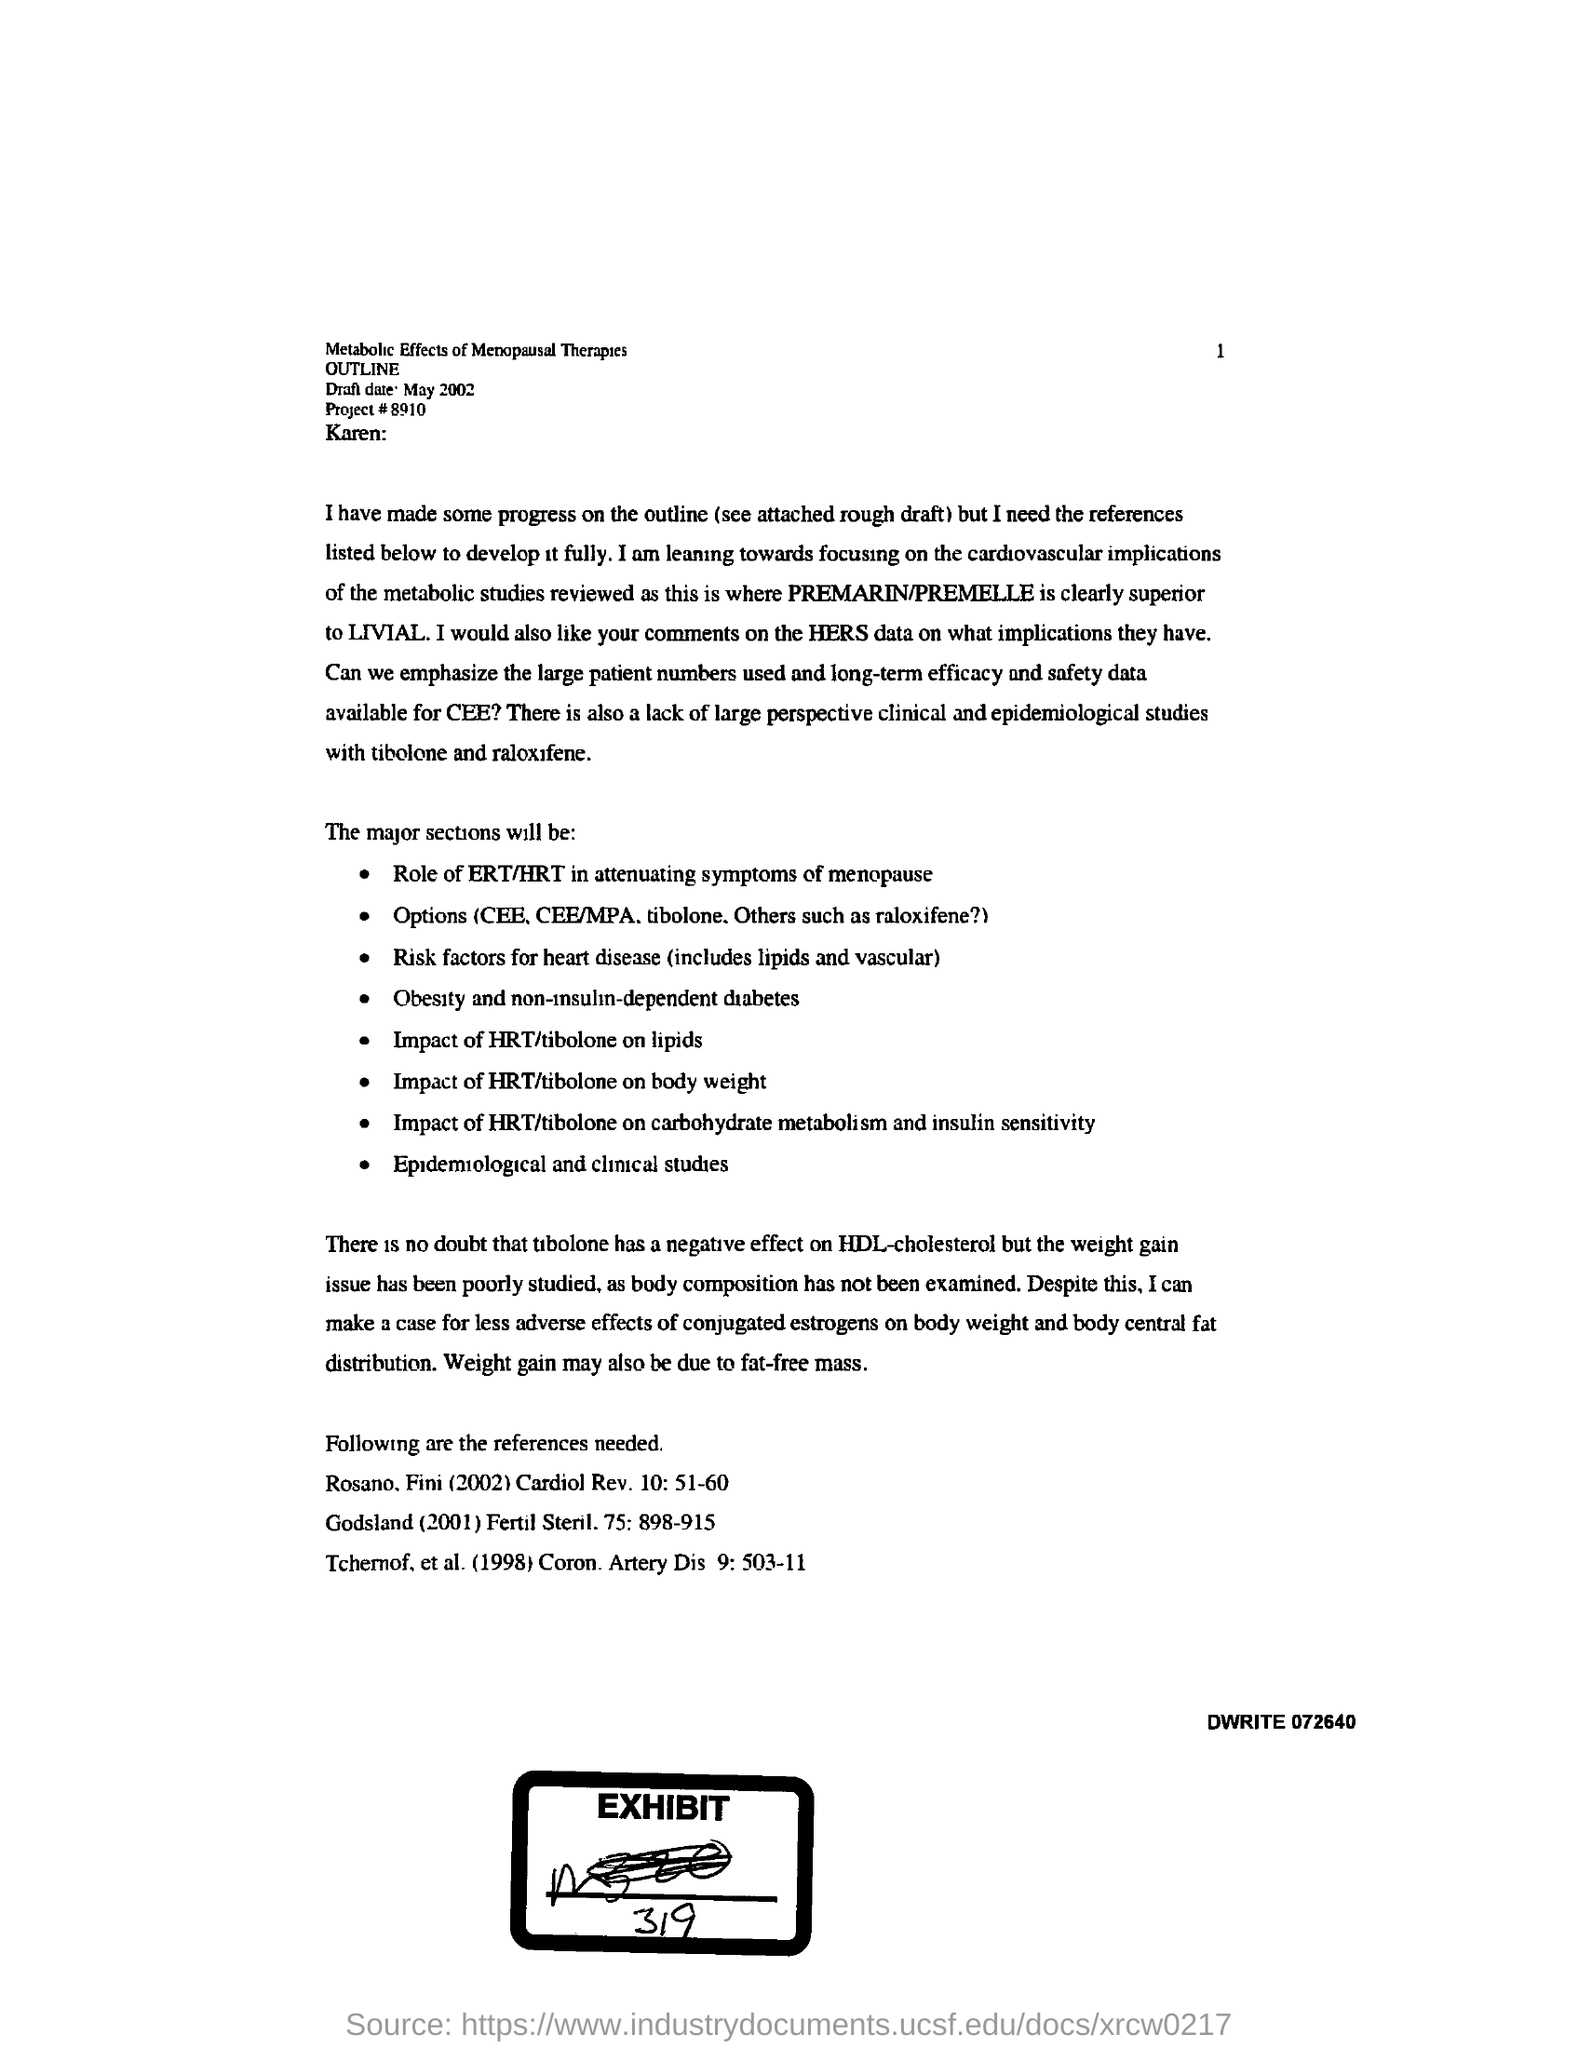When is the Draft Due?
Offer a terse response. May 2002. What is the Project #?
Your answer should be compact. 8910. 